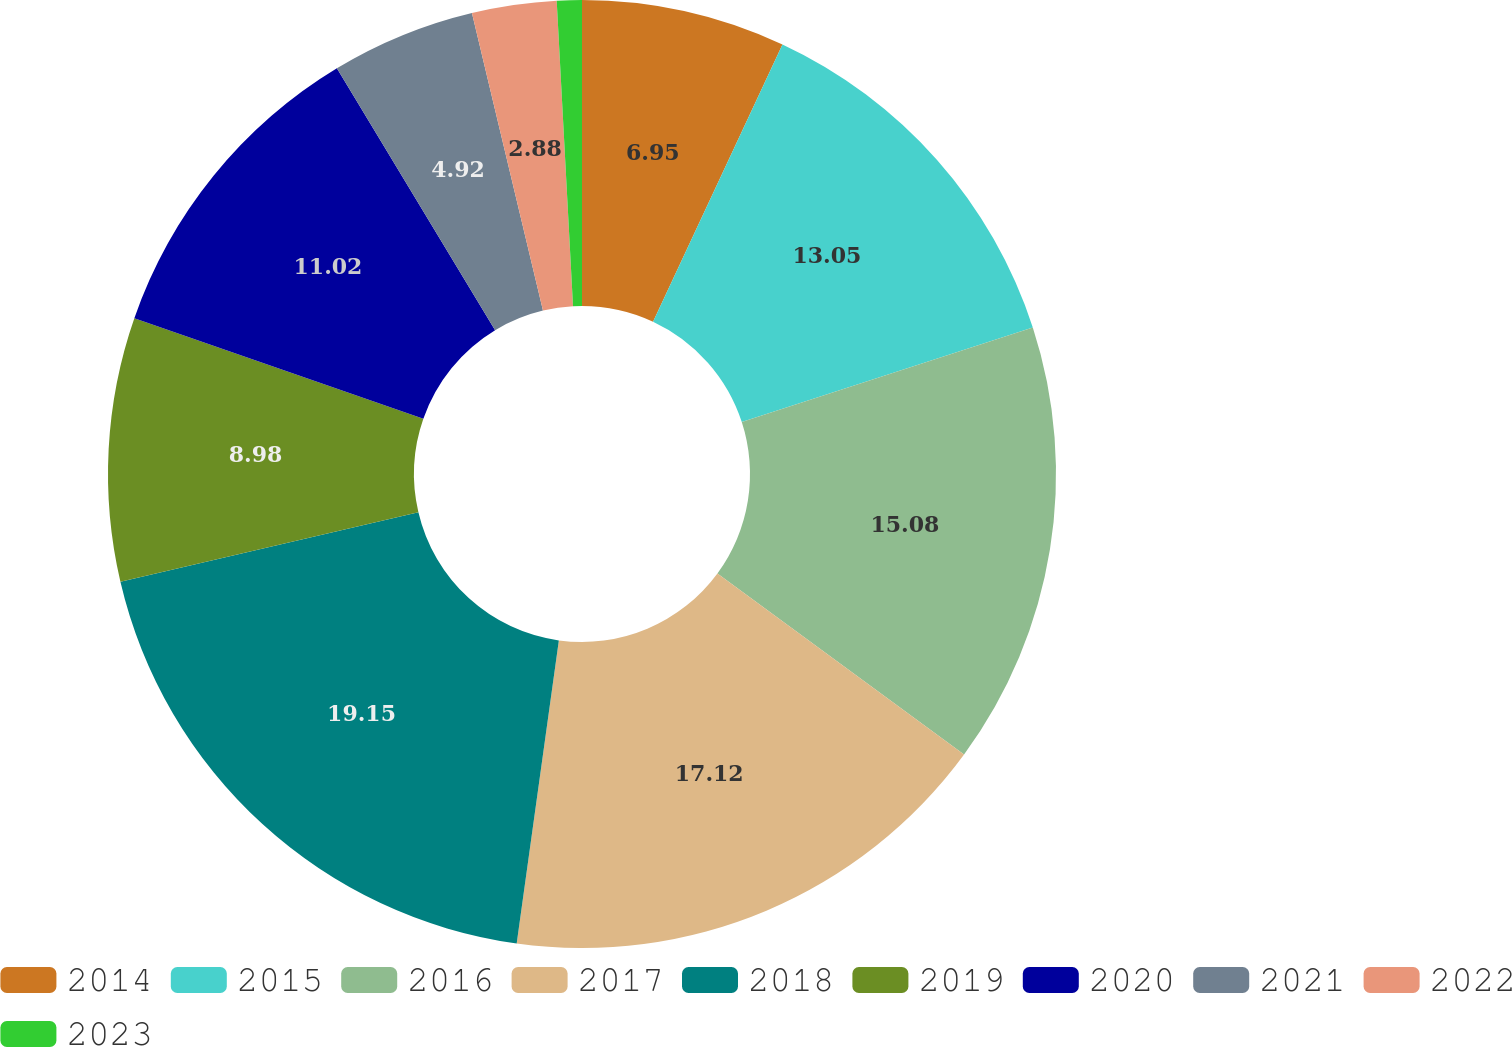Convert chart to OTSL. <chart><loc_0><loc_0><loc_500><loc_500><pie_chart><fcel>2014<fcel>2015<fcel>2016<fcel>2017<fcel>2018<fcel>2019<fcel>2020<fcel>2021<fcel>2022<fcel>2023<nl><fcel>6.95%<fcel>13.05%<fcel>15.08%<fcel>17.12%<fcel>19.15%<fcel>8.98%<fcel>11.02%<fcel>4.92%<fcel>2.88%<fcel>0.85%<nl></chart> 